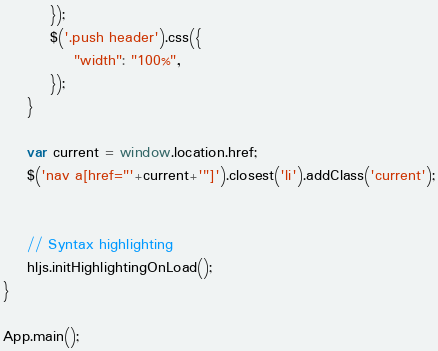<code> <loc_0><loc_0><loc_500><loc_500><_JavaScript_>        });
        $('.push header').css({
            "width": "100%",
        });
    }

    var current = window.location.href;
    $('nav a[href="'+current+'"]').closest('li').addClass('current');


    // Syntax highlighting
    hljs.initHighlightingOnLoad();
}

App.main();
</code> 